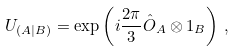Convert formula to latex. <formula><loc_0><loc_0><loc_500><loc_500>U _ { ( A | B ) } = \exp \left ( i \frac { 2 \pi } { 3 } \hat { O } _ { A } \otimes 1 _ { B } \right ) \, ,</formula> 